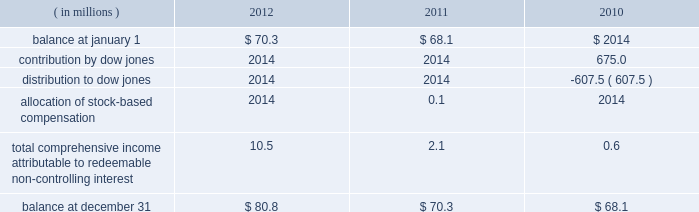Positions and collateral of the defaulting firm at each respective clearing organization , and taking into account any cross-margining loss sharing payments , any of the participating clearing organizations has a remaining liquidating surplus , and any other participating clearing organization has a remaining liquidating deficit , any additional surplus from the liquidation would be shared with the other clearing house to the extent that it has a remaining liquidating deficit .
Any remaining surplus funds would be passed to the bankruptcy trustee .
Mf global bankruptcy trust .
The company provided a $ 550.0 million financial guarantee to the bankruptcy trustee of mf global to accelerate the distribution of funds to mf global customers .
In the event that the trustee distributed more property in the second or third interim distributions than was permitted by the bankruptcy code and cftc regulations , the company will make a cash payment to the trustee for the amount of the erroneous distribution or distributions up to $ 550.0 million in the aggregate .
A payment will only be made after the trustee makes reasonable efforts to collect the property erroneously distributed to the customer ( s ) .
If a payment is made by the company , the company may have the right to seek reimbursement of the erroneously distributed property from the applicable customer ( s ) .
The guarantee does not cover distributions made by the trustee to customers on the basis of their claims filed in the bankruptcy .
Because the trustee has now made payments to nearly all customers on the basis of their claims , the company believes that the likelihood of payment to the trustee is very remote .
As a result , the guarantee liability is estimated to be immaterial at december 31 , 2012 .
Family farmer and rancher protection fund .
In april 2012 , the company established the family farmer and rancher protection fund ( the fund ) .
The fund is designed to provide payments , up to certain maximum levels , to family farmers , ranchers and other agricultural industry participants who use cme group agricultural products and who suffer losses to their segregated account balances due to their cme clearing member becoming insolvent .
Under the terms of the fund , farmers and ranchers are eligible for up to $ 25000 per participant .
Farming and ranching cooperatives are eligible for up to $ 100000 per cooperative .
The fund has an aggregate maximum payment amount of $ 100.0 million .
If payments to participants were to exceed this amount , payments would be pro-rated .
Clearing members and customers must register in advance with the company and provide certain documentation in order to substantiate their eligibility .
Peregrine financial group , inc .
( pfg ) filed for bankruptcy protection on july 10 , 2012 .
Pfg was not one of cme 2019s clearing members and its customers had not registered for the fund .
Accordingly , they were not technically eligible for payments from the fund .
However , because the fund was newly implemented and because pfg 2019s customers included many agricultural industry participants for whom the program was designed , the company decided to waive certain terms and conditions of the fund , solely in connection with the pfg bankruptcy , so that otherwise eligible family farmers , ranchers and agricultural cooperatives could apply for and receive benefits from cme .
Based on the number of such pfg customers who applied and the estimated size of their claims , the company has recorded a liability in the amount of $ 2.1 million at december 31 , 2012 .
16 .
Redeemable non-controlling interest the following summarizes the changes in redeemable non-controlling interest for the years presented .
Non- controlling interests that do not contain redemption features are presented in the statements of equity. .
Contribution by dow jones .
2014 2014 675.0 distribution to dow jones .
2014 2014 ( 607.5 ) allocation of stock- compensation .
2014 0.1 2014 total comprehensive income attributable to redeemable non- controlling interest .
10.5 2.1 0.6 balance at december 31 .
$ 80.8 $ 70.3 $ 68.1 .
What was the percentage change in the redeemable non-controlling in 2012? 
Computations: (10.5 / 70.3)
Answer: 0.14936. 